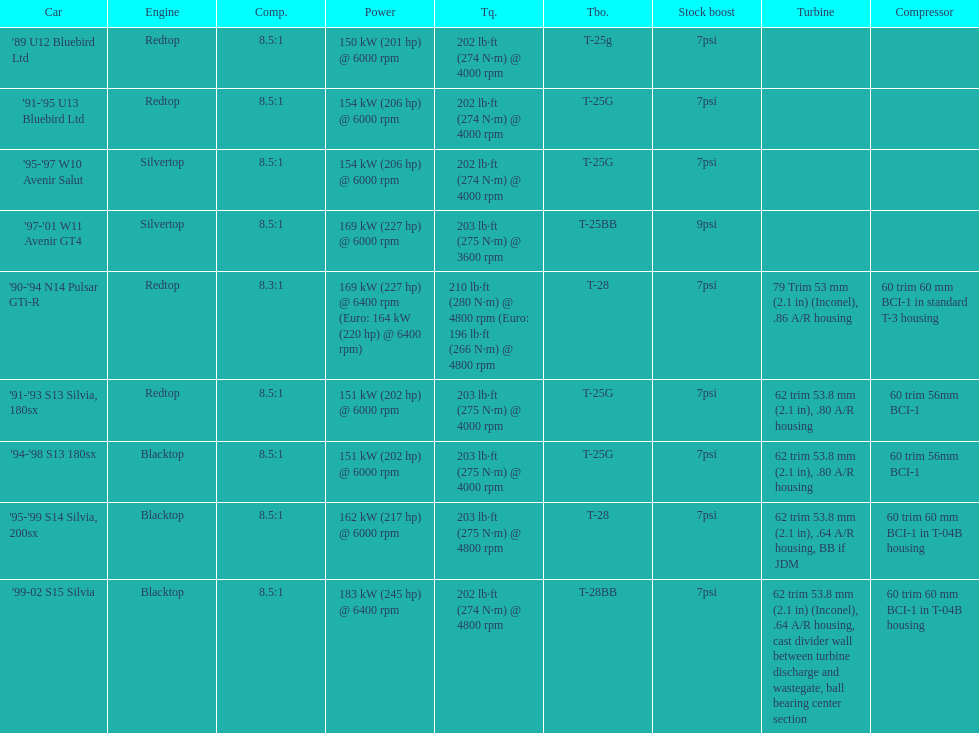Which car has a stock boost of over 7psi? '97-'01 W11 Avenir GT4. 